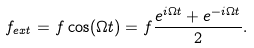Convert formula to latex. <formula><loc_0><loc_0><loc_500><loc_500>f _ { e x t } = f \cos ( \Omega t ) = f \frac { e ^ { i \Omega t } + e ^ { - i \Omega t } } { 2 } .</formula> 